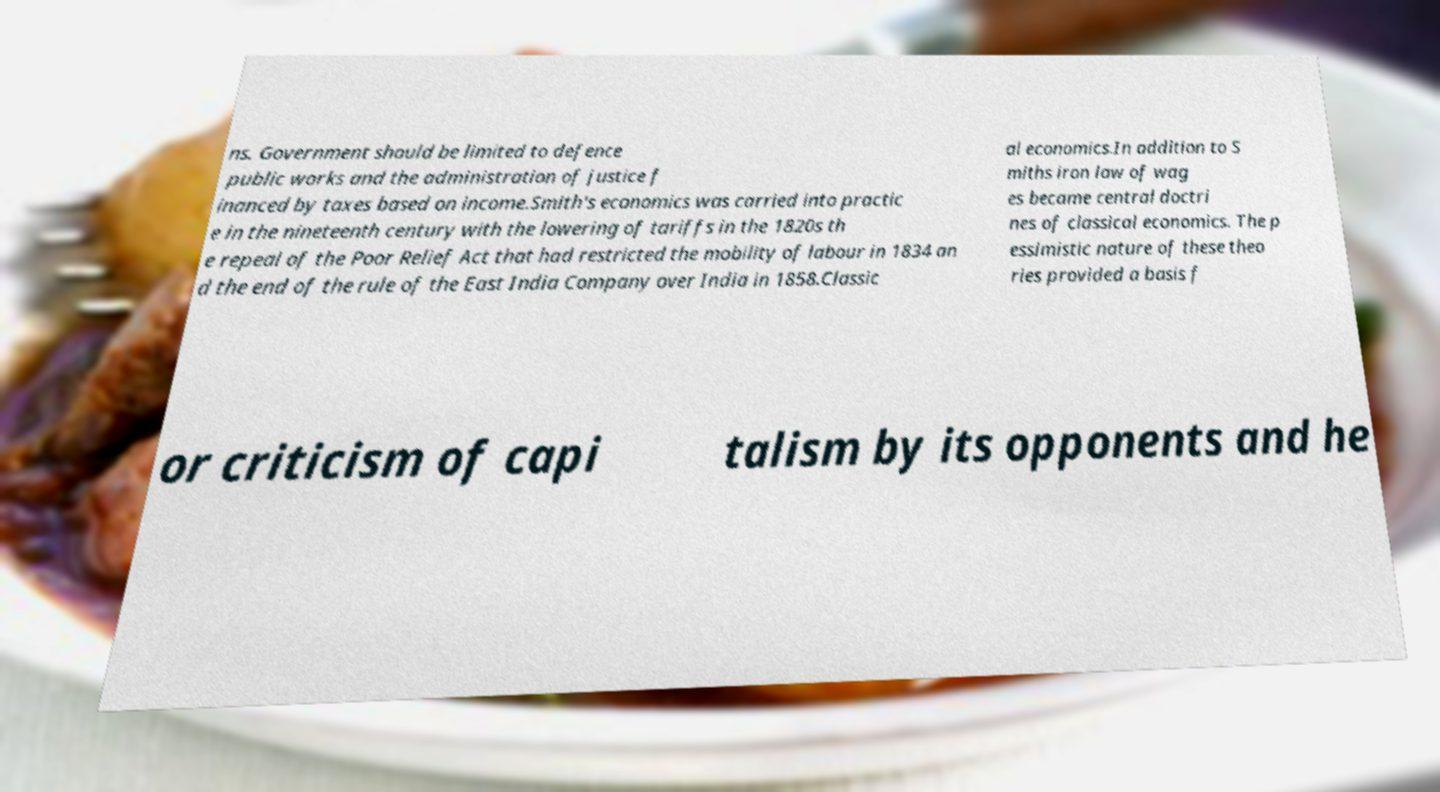For documentation purposes, I need the text within this image transcribed. Could you provide that? ns. Government should be limited to defence public works and the administration of justice f inanced by taxes based on income.Smith's economics was carried into practic e in the nineteenth century with the lowering of tariffs in the 1820s th e repeal of the Poor Relief Act that had restricted the mobility of labour in 1834 an d the end of the rule of the East India Company over India in 1858.Classic al economics.In addition to S miths iron law of wag es became central doctri nes of classical economics. The p essimistic nature of these theo ries provided a basis f or criticism of capi talism by its opponents and he 